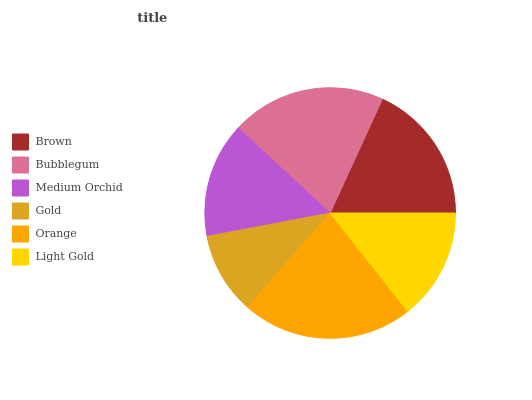Is Gold the minimum?
Answer yes or no. Yes. Is Orange the maximum?
Answer yes or no. Yes. Is Bubblegum the minimum?
Answer yes or no. No. Is Bubblegum the maximum?
Answer yes or no. No. Is Bubblegum greater than Brown?
Answer yes or no. Yes. Is Brown less than Bubblegum?
Answer yes or no. Yes. Is Brown greater than Bubblegum?
Answer yes or no. No. Is Bubblegum less than Brown?
Answer yes or no. No. Is Brown the high median?
Answer yes or no. Yes. Is Medium Orchid the low median?
Answer yes or no. Yes. Is Light Gold the high median?
Answer yes or no. No. Is Brown the low median?
Answer yes or no. No. 